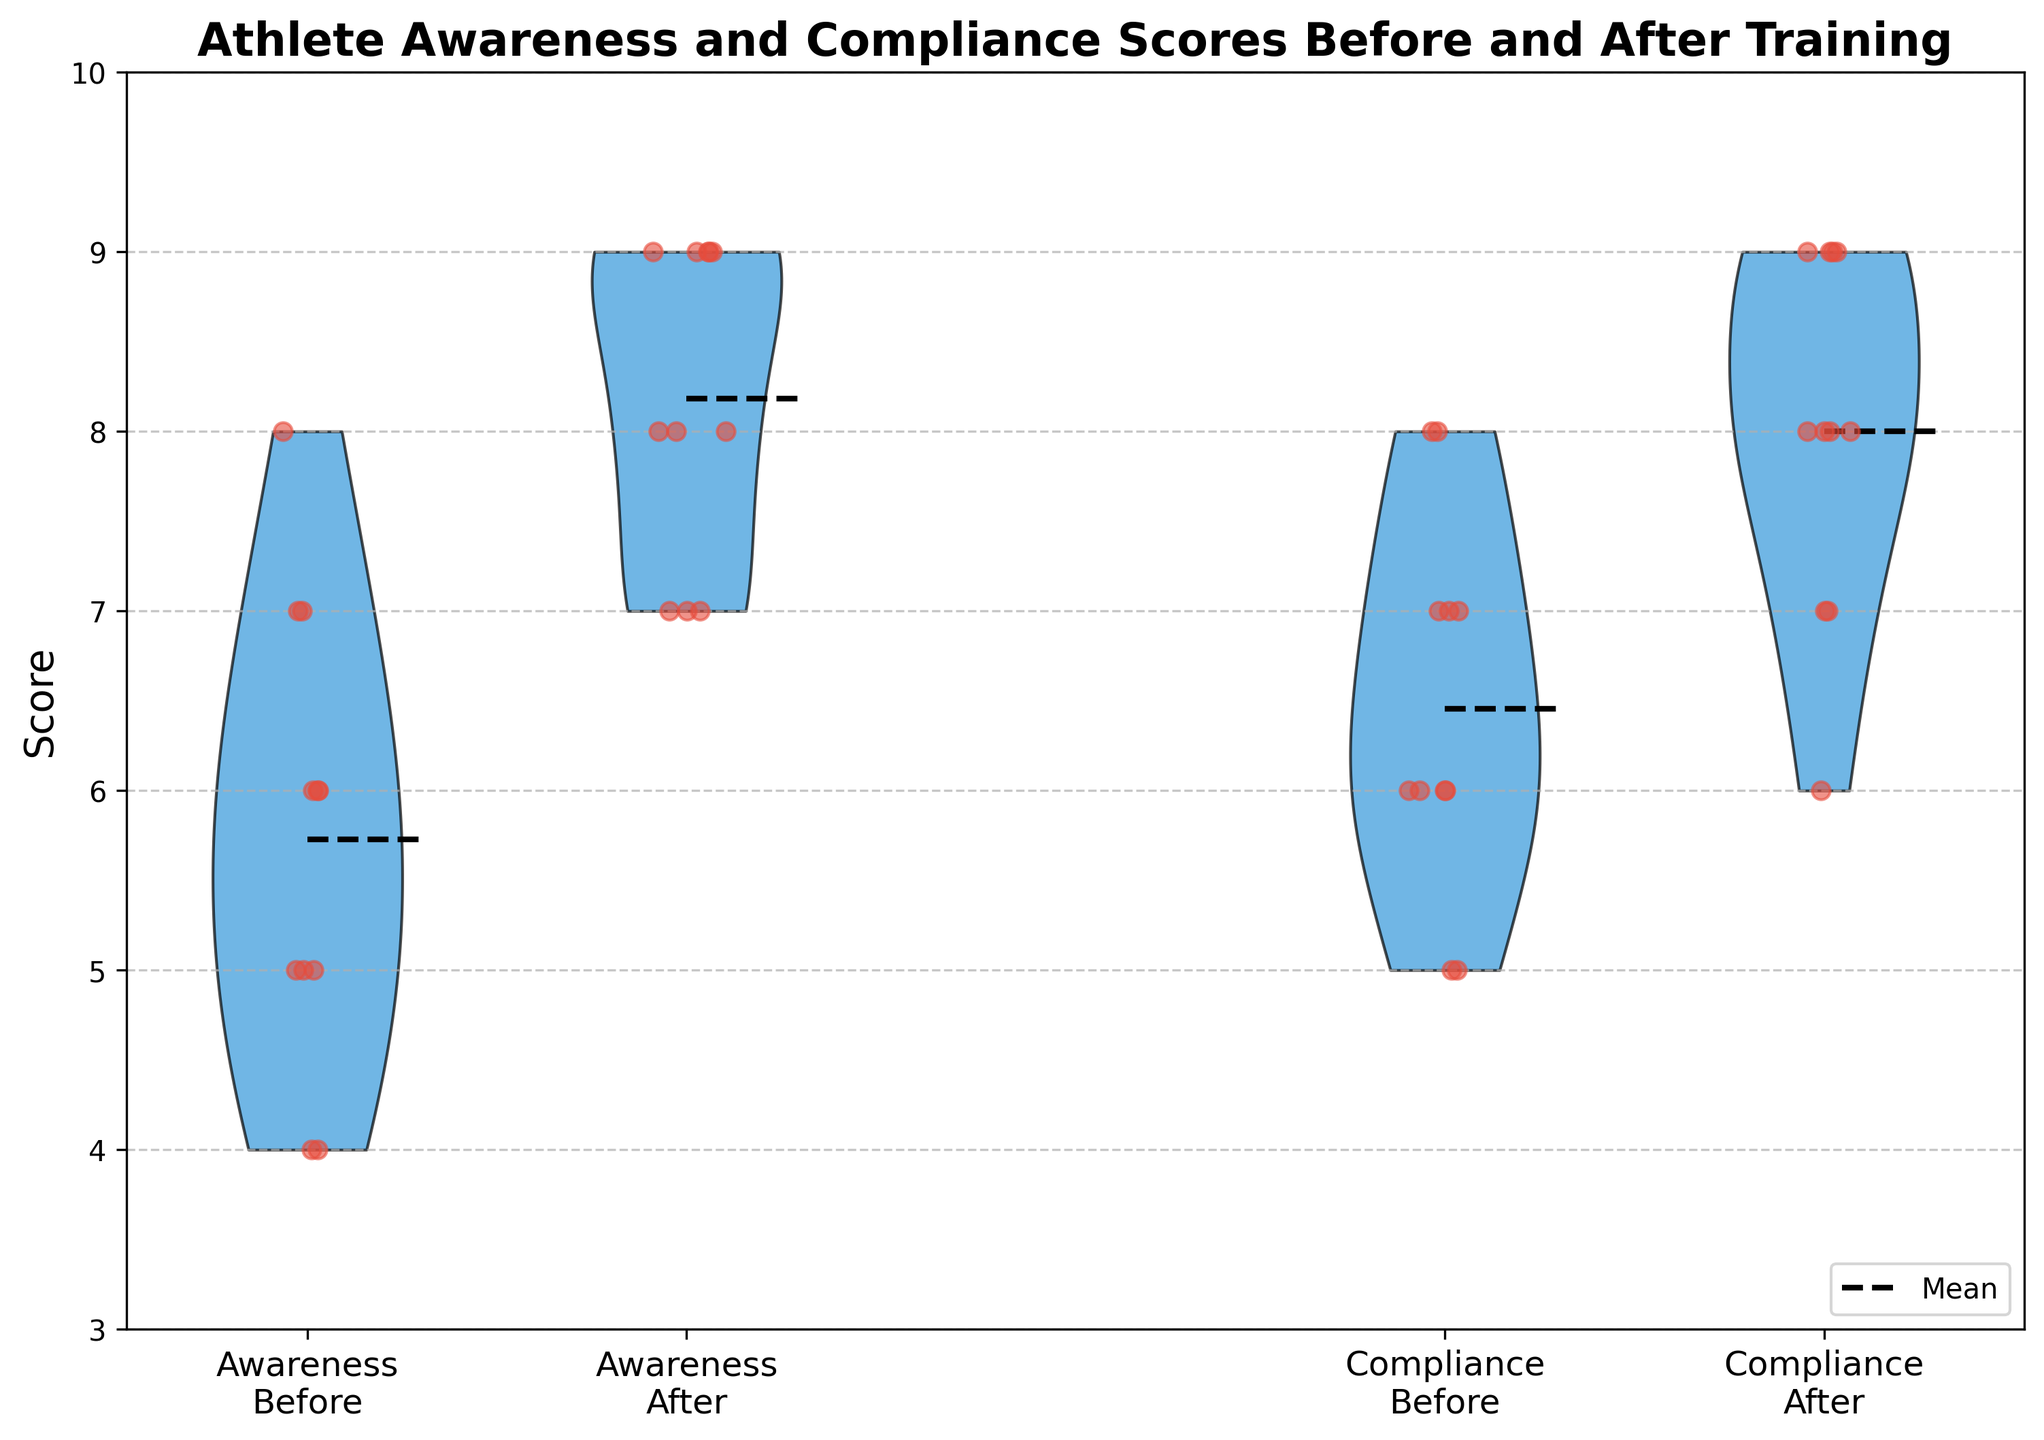what is the title of the chart? The title is typically found at the top-center of the chart and describes what the chart is about.
Answer: Athlete Awareness and Compliance Scores Before and After Training What is the y-axis representing in this chart? The y-axis indicates the scale of scores that measure awareness and compliance, ranging from 3 to 10.
Answer: Score What colors are used for the violin plots and the jittered points? The chart uses blue for the violin plots and red for the jittered points.
Answer: Blue (violin plots) and red (jittered points) Which session, before or after, has a higher mean awareness score? Compare the mean lines for awareness scores before and after training. The "after" session has a higher mean.
Answer: After By how much does the mean awareness score increase from before to after training? Find the mean awareness score for "before" and "after" from the mean lines. The mean increases by (mean after) - (mean before).
Answer: 2 Which score category, awareness before or compliance after, has the widest spread? Examine the width of the violin plots. The wider the plot, the more spread out the scores are.
Answer: Awareness before How many scores are jittered around the compliance before position? Count the number of red points around the compliance before violin plot position.
Answer: 14 Is there a noticeable difference in the median compliance scores before and after training? Even though medians are not explicitly shown, the overall shape and concentration of points can provide insight. The medians appear close but might be slightly higher in the "after" session.
Answer: Slight increase after Are the awareness scores distributed symmetrically after training? Assess the shape of the "after" violin plot for awareness. Symmetry indicates a balanced distribution around the center.
Answer: Yes How does the compliance score variability change from before to after training? Compare the widths and spreads of the compliance scores' violin plots. The "after" plot is more compact, indicating reduced variability.
Answer: Decreases 